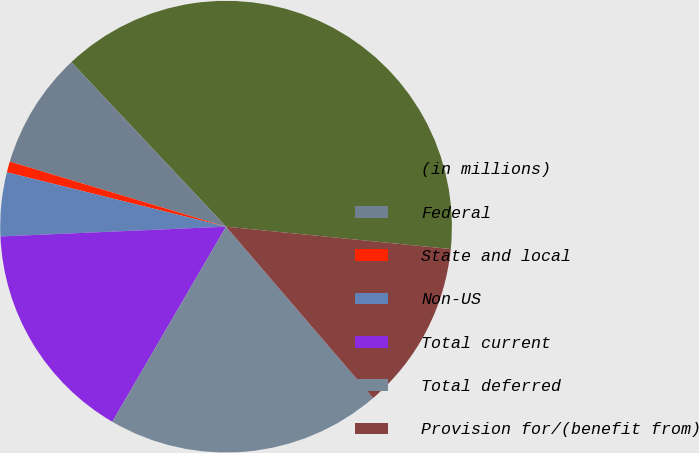Convert chart. <chart><loc_0><loc_0><loc_500><loc_500><pie_chart><fcel>(in millions)<fcel>Federal<fcel>State and local<fcel>Non-US<fcel>Total current<fcel>Total deferred<fcel>Provision for/(benefit from)<nl><fcel>38.59%<fcel>8.34%<fcel>0.78%<fcel>4.56%<fcel>15.91%<fcel>19.69%<fcel>12.13%<nl></chart> 